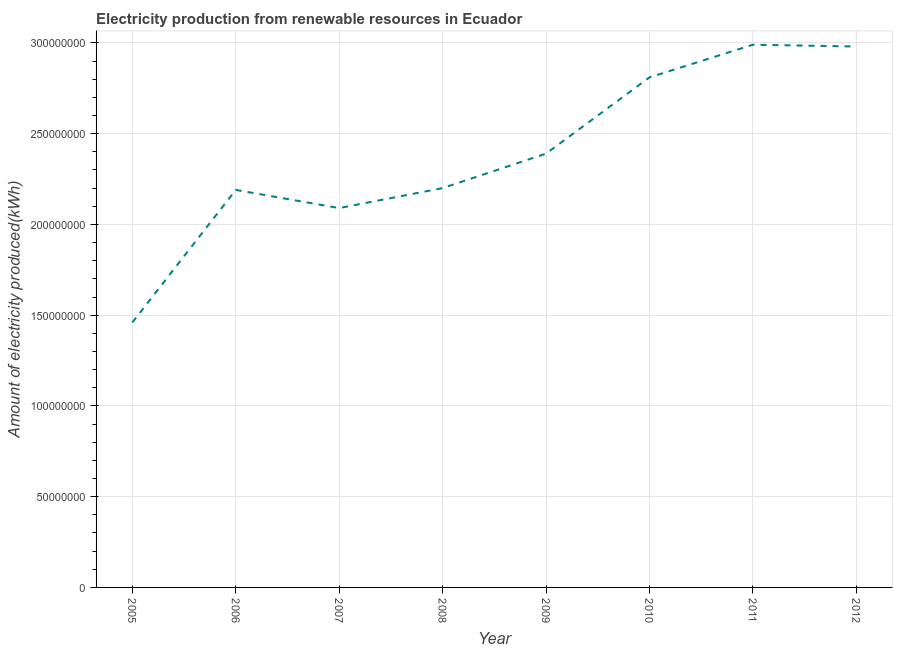What is the amount of electricity produced in 2006?
Keep it short and to the point. 2.19e+08. Across all years, what is the maximum amount of electricity produced?
Ensure brevity in your answer.  2.99e+08. Across all years, what is the minimum amount of electricity produced?
Give a very brief answer. 1.46e+08. In which year was the amount of electricity produced maximum?
Offer a very short reply. 2011. In which year was the amount of electricity produced minimum?
Give a very brief answer. 2005. What is the sum of the amount of electricity produced?
Provide a succinct answer. 1.91e+09. What is the difference between the amount of electricity produced in 2006 and 2007?
Your response must be concise. 1.00e+07. What is the average amount of electricity produced per year?
Your response must be concise. 2.39e+08. What is the median amount of electricity produced?
Your answer should be very brief. 2.30e+08. What is the ratio of the amount of electricity produced in 2006 to that in 2009?
Offer a very short reply. 0.92. Is the amount of electricity produced in 2009 less than that in 2010?
Your answer should be very brief. Yes. What is the difference between the highest and the lowest amount of electricity produced?
Your answer should be very brief. 1.53e+08. In how many years, is the amount of electricity produced greater than the average amount of electricity produced taken over all years?
Offer a very short reply. 4. Does the amount of electricity produced monotonically increase over the years?
Provide a succinct answer. No. Does the graph contain grids?
Provide a short and direct response. Yes. What is the title of the graph?
Your answer should be compact. Electricity production from renewable resources in Ecuador. What is the label or title of the X-axis?
Your answer should be compact. Year. What is the label or title of the Y-axis?
Make the answer very short. Amount of electricity produced(kWh). What is the Amount of electricity produced(kWh) in 2005?
Provide a succinct answer. 1.46e+08. What is the Amount of electricity produced(kWh) of 2006?
Make the answer very short. 2.19e+08. What is the Amount of electricity produced(kWh) in 2007?
Offer a very short reply. 2.09e+08. What is the Amount of electricity produced(kWh) in 2008?
Your response must be concise. 2.20e+08. What is the Amount of electricity produced(kWh) of 2009?
Your response must be concise. 2.39e+08. What is the Amount of electricity produced(kWh) of 2010?
Give a very brief answer. 2.81e+08. What is the Amount of electricity produced(kWh) of 2011?
Offer a terse response. 2.99e+08. What is the Amount of electricity produced(kWh) in 2012?
Provide a short and direct response. 2.98e+08. What is the difference between the Amount of electricity produced(kWh) in 2005 and 2006?
Make the answer very short. -7.30e+07. What is the difference between the Amount of electricity produced(kWh) in 2005 and 2007?
Keep it short and to the point. -6.30e+07. What is the difference between the Amount of electricity produced(kWh) in 2005 and 2008?
Give a very brief answer. -7.40e+07. What is the difference between the Amount of electricity produced(kWh) in 2005 and 2009?
Ensure brevity in your answer.  -9.30e+07. What is the difference between the Amount of electricity produced(kWh) in 2005 and 2010?
Offer a very short reply. -1.35e+08. What is the difference between the Amount of electricity produced(kWh) in 2005 and 2011?
Provide a short and direct response. -1.53e+08. What is the difference between the Amount of electricity produced(kWh) in 2005 and 2012?
Keep it short and to the point. -1.52e+08. What is the difference between the Amount of electricity produced(kWh) in 2006 and 2007?
Give a very brief answer. 1.00e+07. What is the difference between the Amount of electricity produced(kWh) in 2006 and 2008?
Provide a succinct answer. -1.00e+06. What is the difference between the Amount of electricity produced(kWh) in 2006 and 2009?
Offer a very short reply. -2.00e+07. What is the difference between the Amount of electricity produced(kWh) in 2006 and 2010?
Your answer should be compact. -6.20e+07. What is the difference between the Amount of electricity produced(kWh) in 2006 and 2011?
Offer a very short reply. -8.00e+07. What is the difference between the Amount of electricity produced(kWh) in 2006 and 2012?
Ensure brevity in your answer.  -7.90e+07. What is the difference between the Amount of electricity produced(kWh) in 2007 and 2008?
Make the answer very short. -1.10e+07. What is the difference between the Amount of electricity produced(kWh) in 2007 and 2009?
Offer a very short reply. -3.00e+07. What is the difference between the Amount of electricity produced(kWh) in 2007 and 2010?
Offer a very short reply. -7.20e+07. What is the difference between the Amount of electricity produced(kWh) in 2007 and 2011?
Your answer should be very brief. -9.00e+07. What is the difference between the Amount of electricity produced(kWh) in 2007 and 2012?
Your answer should be compact. -8.90e+07. What is the difference between the Amount of electricity produced(kWh) in 2008 and 2009?
Offer a terse response. -1.90e+07. What is the difference between the Amount of electricity produced(kWh) in 2008 and 2010?
Offer a very short reply. -6.10e+07. What is the difference between the Amount of electricity produced(kWh) in 2008 and 2011?
Offer a terse response. -7.90e+07. What is the difference between the Amount of electricity produced(kWh) in 2008 and 2012?
Offer a terse response. -7.80e+07. What is the difference between the Amount of electricity produced(kWh) in 2009 and 2010?
Ensure brevity in your answer.  -4.20e+07. What is the difference between the Amount of electricity produced(kWh) in 2009 and 2011?
Your answer should be very brief. -6.00e+07. What is the difference between the Amount of electricity produced(kWh) in 2009 and 2012?
Your answer should be very brief. -5.90e+07. What is the difference between the Amount of electricity produced(kWh) in 2010 and 2011?
Your answer should be compact. -1.80e+07. What is the difference between the Amount of electricity produced(kWh) in 2010 and 2012?
Make the answer very short. -1.70e+07. What is the ratio of the Amount of electricity produced(kWh) in 2005 to that in 2006?
Provide a short and direct response. 0.67. What is the ratio of the Amount of electricity produced(kWh) in 2005 to that in 2007?
Ensure brevity in your answer.  0.7. What is the ratio of the Amount of electricity produced(kWh) in 2005 to that in 2008?
Your answer should be very brief. 0.66. What is the ratio of the Amount of electricity produced(kWh) in 2005 to that in 2009?
Keep it short and to the point. 0.61. What is the ratio of the Amount of electricity produced(kWh) in 2005 to that in 2010?
Give a very brief answer. 0.52. What is the ratio of the Amount of electricity produced(kWh) in 2005 to that in 2011?
Your answer should be very brief. 0.49. What is the ratio of the Amount of electricity produced(kWh) in 2005 to that in 2012?
Your answer should be compact. 0.49. What is the ratio of the Amount of electricity produced(kWh) in 2006 to that in 2007?
Make the answer very short. 1.05. What is the ratio of the Amount of electricity produced(kWh) in 2006 to that in 2008?
Your answer should be compact. 0.99. What is the ratio of the Amount of electricity produced(kWh) in 2006 to that in 2009?
Make the answer very short. 0.92. What is the ratio of the Amount of electricity produced(kWh) in 2006 to that in 2010?
Ensure brevity in your answer.  0.78. What is the ratio of the Amount of electricity produced(kWh) in 2006 to that in 2011?
Your answer should be compact. 0.73. What is the ratio of the Amount of electricity produced(kWh) in 2006 to that in 2012?
Provide a short and direct response. 0.73. What is the ratio of the Amount of electricity produced(kWh) in 2007 to that in 2008?
Ensure brevity in your answer.  0.95. What is the ratio of the Amount of electricity produced(kWh) in 2007 to that in 2009?
Your answer should be compact. 0.87. What is the ratio of the Amount of electricity produced(kWh) in 2007 to that in 2010?
Make the answer very short. 0.74. What is the ratio of the Amount of electricity produced(kWh) in 2007 to that in 2011?
Ensure brevity in your answer.  0.7. What is the ratio of the Amount of electricity produced(kWh) in 2007 to that in 2012?
Keep it short and to the point. 0.7. What is the ratio of the Amount of electricity produced(kWh) in 2008 to that in 2009?
Ensure brevity in your answer.  0.92. What is the ratio of the Amount of electricity produced(kWh) in 2008 to that in 2010?
Your answer should be compact. 0.78. What is the ratio of the Amount of electricity produced(kWh) in 2008 to that in 2011?
Make the answer very short. 0.74. What is the ratio of the Amount of electricity produced(kWh) in 2008 to that in 2012?
Provide a short and direct response. 0.74. What is the ratio of the Amount of electricity produced(kWh) in 2009 to that in 2010?
Provide a short and direct response. 0.85. What is the ratio of the Amount of electricity produced(kWh) in 2009 to that in 2011?
Keep it short and to the point. 0.8. What is the ratio of the Amount of electricity produced(kWh) in 2009 to that in 2012?
Ensure brevity in your answer.  0.8. What is the ratio of the Amount of electricity produced(kWh) in 2010 to that in 2011?
Provide a short and direct response. 0.94. What is the ratio of the Amount of electricity produced(kWh) in 2010 to that in 2012?
Offer a terse response. 0.94. 